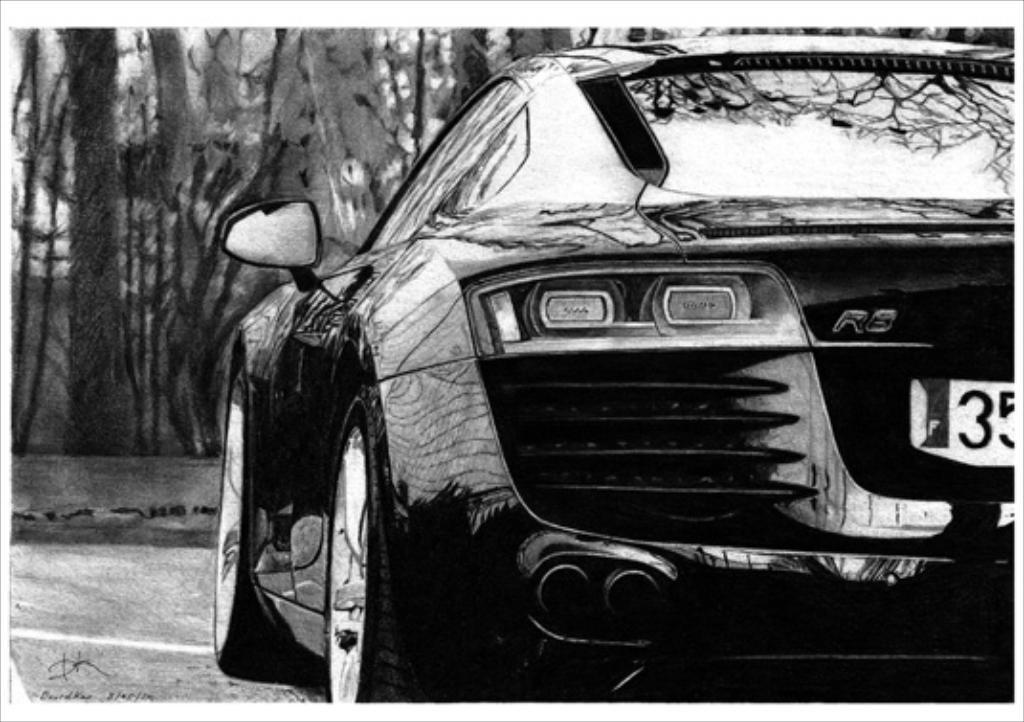What is the main subject of the image? The main subject of the image is a car. How is the car depicted in the image? The car is truncated towards the right side of the image. What else can be seen in the image besides the car? There is a road and trees in the image. How are the trees depicted in the image? The trees are truncated towards the top of the image. What type of garden can be seen in the image? There is no garden present in the image; it features a car, road, and trees. What kind of lace is used to decorate the car in the image? There is no lace present on the car in the image. 